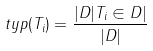<formula> <loc_0><loc_0><loc_500><loc_500>t y p ( T _ { i } ) = \frac { | D | T _ { i } \in D | } { | D | }</formula> 